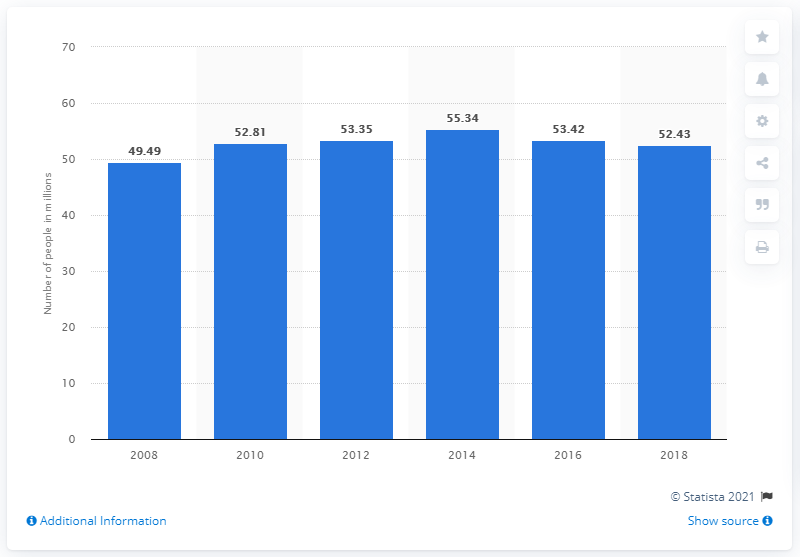List a handful of essential elements in this visual. In 2018, it was estimated that 52.43% of the population in Mexico lived in a situation of poverty. 